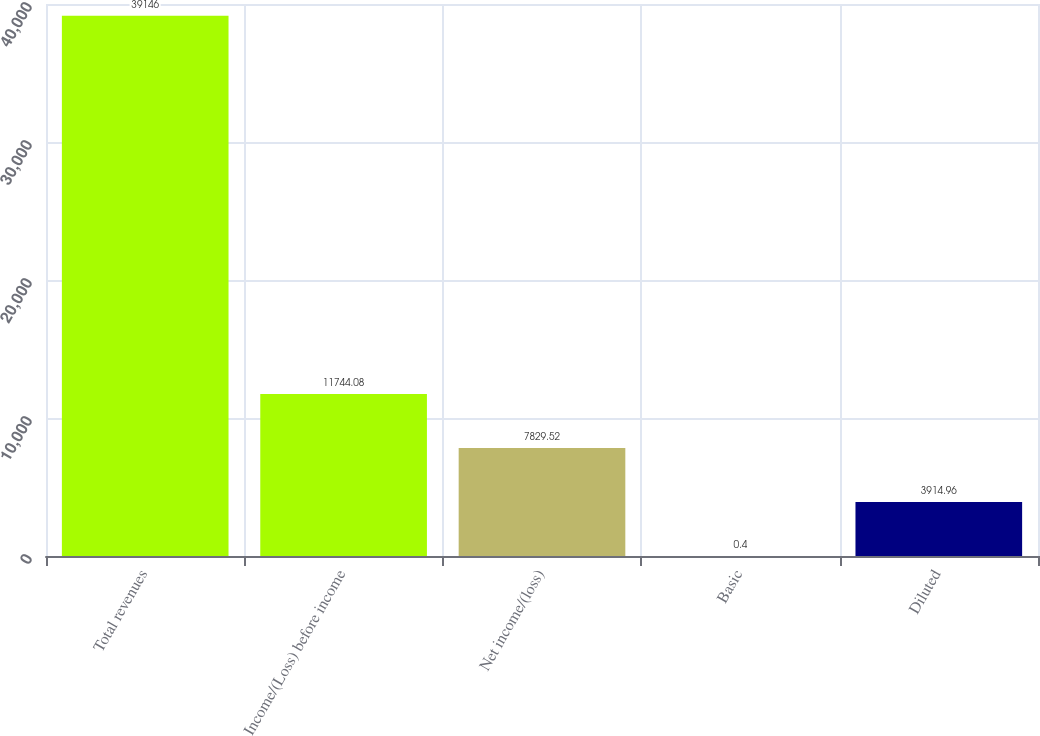<chart> <loc_0><loc_0><loc_500><loc_500><bar_chart><fcel>Total revenues<fcel>Income/(Loss) before income<fcel>Net income/(loss)<fcel>Basic<fcel>Diluted<nl><fcel>39146<fcel>11744.1<fcel>7829.52<fcel>0.4<fcel>3914.96<nl></chart> 